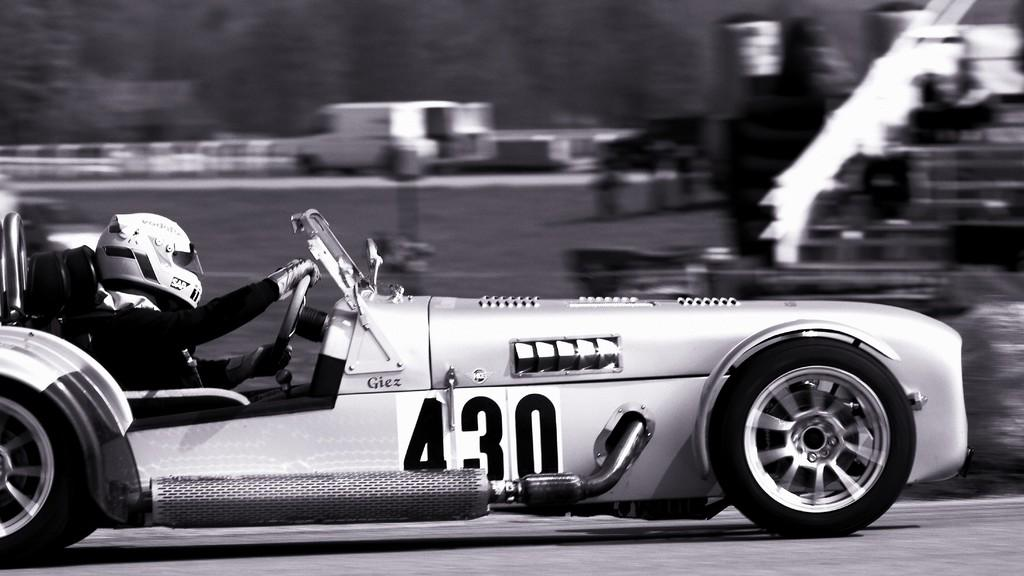What is the person in the image doing? There is a person riding a car in the image. What safety precaution is the person taking while riding the car? The person is wearing a helmet. What type of egg is the person holding in the image? There is no egg present in the image; the person is riding a car and wearing a helmet. 